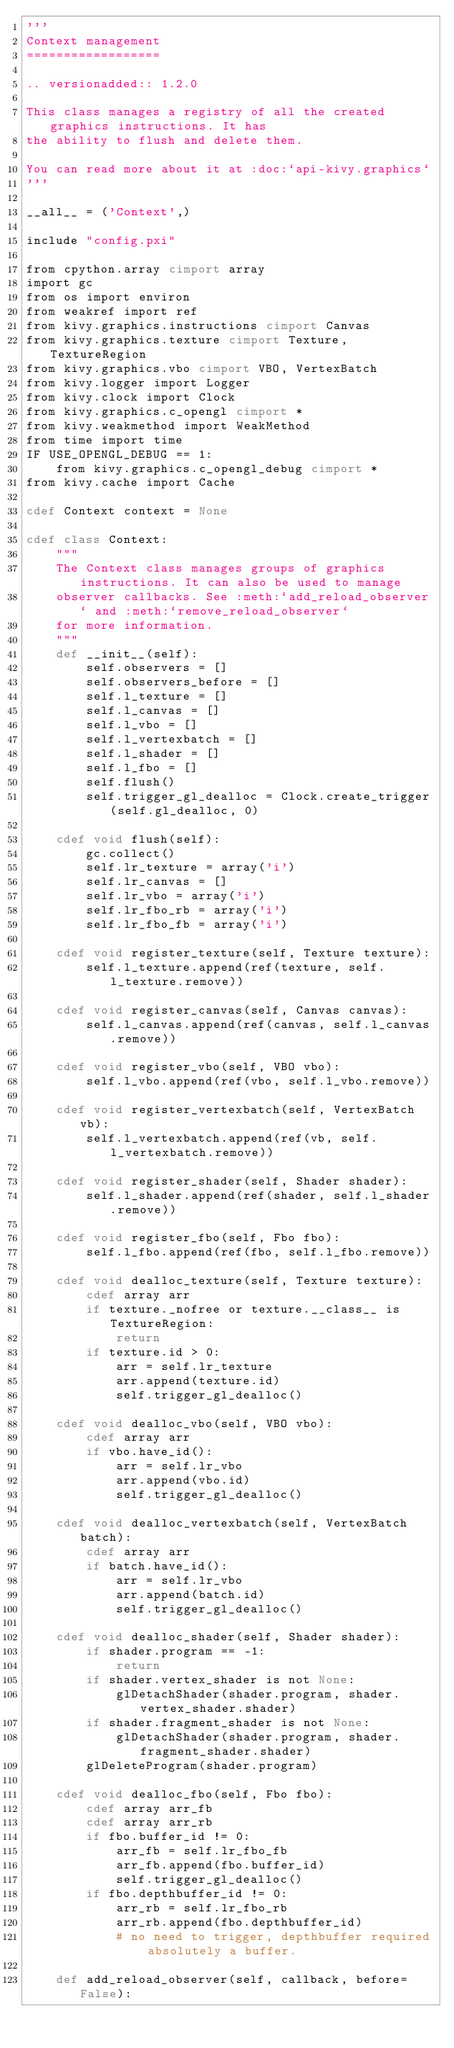Convert code to text. <code><loc_0><loc_0><loc_500><loc_500><_Cython_>'''
Context management
==================

.. versionadded:: 1.2.0

This class manages a registry of all the created graphics instructions. It has
the ability to flush and delete them.

You can read more about it at :doc:`api-kivy.graphics`
'''

__all__ = ('Context',)

include "config.pxi"

from cpython.array cimport array
import gc
from os import environ
from weakref import ref
from kivy.graphics.instructions cimport Canvas
from kivy.graphics.texture cimport Texture, TextureRegion
from kivy.graphics.vbo cimport VBO, VertexBatch
from kivy.logger import Logger
from kivy.clock import Clock
from kivy.graphics.c_opengl cimport *
from kivy.weakmethod import WeakMethod
from time import time
IF USE_OPENGL_DEBUG == 1:
    from kivy.graphics.c_opengl_debug cimport *
from kivy.cache import Cache

cdef Context context = None

cdef class Context:
    """
    The Context class manages groups of graphics instructions. It can also be used to manage
    observer callbacks. See :meth:`add_reload_observer` and :meth:`remove_reload_observer`
    for more information.
    """
    def __init__(self):
        self.observers = []
        self.observers_before = []
        self.l_texture = []
        self.l_canvas = []
        self.l_vbo = []
        self.l_vertexbatch = []
        self.l_shader = []
        self.l_fbo = []
        self.flush()
        self.trigger_gl_dealloc = Clock.create_trigger(self.gl_dealloc, 0)

    cdef void flush(self):
        gc.collect()
        self.lr_texture = array('i')
        self.lr_canvas = []
        self.lr_vbo = array('i')
        self.lr_fbo_rb = array('i')
        self.lr_fbo_fb = array('i')

    cdef void register_texture(self, Texture texture):
        self.l_texture.append(ref(texture, self.l_texture.remove))

    cdef void register_canvas(self, Canvas canvas):
        self.l_canvas.append(ref(canvas, self.l_canvas.remove))

    cdef void register_vbo(self, VBO vbo):
        self.l_vbo.append(ref(vbo, self.l_vbo.remove))

    cdef void register_vertexbatch(self, VertexBatch vb):
        self.l_vertexbatch.append(ref(vb, self.l_vertexbatch.remove))

    cdef void register_shader(self, Shader shader):
        self.l_shader.append(ref(shader, self.l_shader.remove))

    cdef void register_fbo(self, Fbo fbo):
        self.l_fbo.append(ref(fbo, self.l_fbo.remove))

    cdef void dealloc_texture(self, Texture texture):
        cdef array arr
        if texture._nofree or texture.__class__ is TextureRegion:
            return
        if texture.id > 0:
            arr = self.lr_texture
            arr.append(texture.id)
            self.trigger_gl_dealloc()

    cdef void dealloc_vbo(self, VBO vbo):
        cdef array arr
        if vbo.have_id():
            arr = self.lr_vbo
            arr.append(vbo.id)
            self.trigger_gl_dealloc()

    cdef void dealloc_vertexbatch(self, VertexBatch batch):
        cdef array arr
        if batch.have_id():
            arr = self.lr_vbo
            arr.append(batch.id)
            self.trigger_gl_dealloc()

    cdef void dealloc_shader(self, Shader shader):
        if shader.program == -1:
            return
        if shader.vertex_shader is not None:
            glDetachShader(shader.program, shader.vertex_shader.shader)
        if shader.fragment_shader is not None:
            glDetachShader(shader.program, shader.fragment_shader.shader)
        glDeleteProgram(shader.program)

    cdef void dealloc_fbo(self, Fbo fbo):
        cdef array arr_fb
        cdef array arr_rb
        if fbo.buffer_id != 0:
            arr_fb = self.lr_fbo_fb
            arr_fb.append(fbo.buffer_id)
            self.trigger_gl_dealloc()
        if fbo.depthbuffer_id != 0:
            arr_rb = self.lr_fbo_rb
            arr_rb.append(fbo.depthbuffer_id)
            # no need to trigger, depthbuffer required absolutely a buffer.

    def add_reload_observer(self, callback, before=False):</code> 